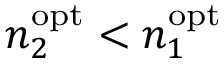<formula> <loc_0><loc_0><loc_500><loc_500>n _ { 2 } ^ { o p t } < n _ { 1 } ^ { o p t }</formula> 